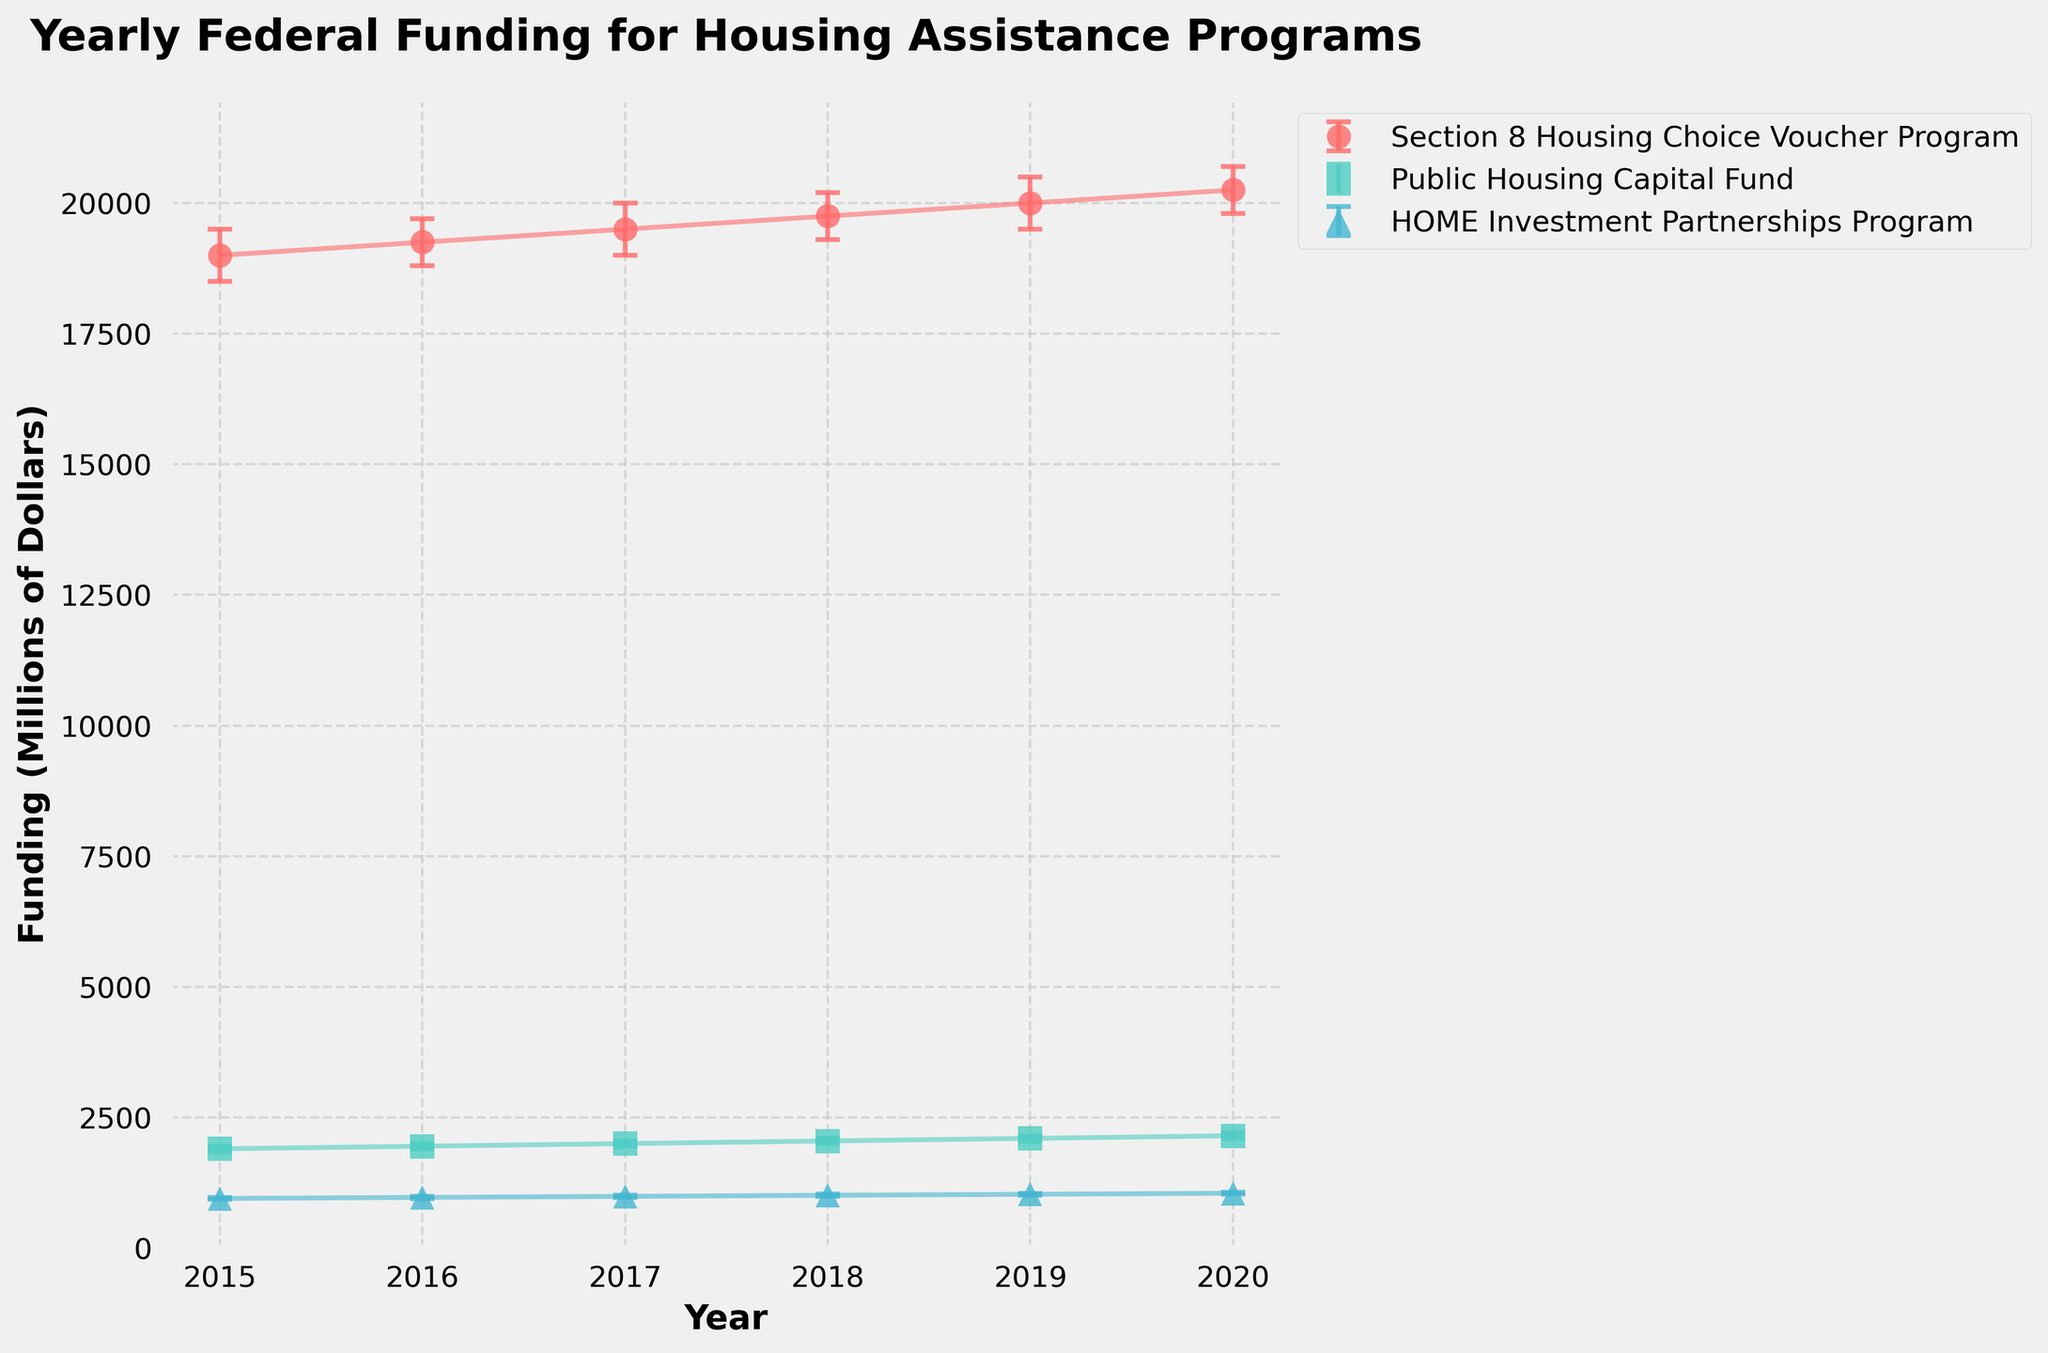What is the title of the figure? The title of the figure is located at the top and provides a brief description of what the plot represents.
Answer: Yearly Federal Funding for Housing Assistance Programs What are the x-axis and y-axis labels in the plot? The x-axis label is typically below the horizontal axis and the y-axis label is typically beside the vertical axis. For this plot:
- The x-axis label is "Year".
- The y-axis label is "Funding (Millions of Dollars)".
Answer: x-axis: Year, y-axis: Funding (Millions of Dollars) What program received the highest funding in 2020? By locating the data point for the year 2020 on the x-axis and then identifying the highest data point along the y-axis, the Section 8 Housing Choice Voucher Program received the highest funding in 2020.
Answer: Section 8 Housing Choice Voucher Program Which year shows the lowest funding for the HOME Investment Partnerships Program, and what is that amount? By tracking the HOME Investment Partnerships Program across the years and identifying the lowest data point, the lowest funding occurs in 2015, with the amount being 950 million dollars.
Answer: 2015, 950 million dollars How does the funding for the Public Housing Capital Fund change from 2015 to 2020? By observing the data points for the Public Housing Capital Fund from 2015 to 2020, we see an increase from 1900 million dollars in 2015 to 2150 million dollars in 2020.
Answer: Increases from 1900 million dollars to 2150 million dollars Which program shows the smallest change in average funding from 2015 to 2020? By calculating the funding change for each program between 2015 and 2020:
- Section 8 Housing Choice Voucher Program: 20250 - 19000 = 1250
- Public Housing Capital Fund: 2150 - 1900 = 250
- HOME Investment Partnerships Program: 1050 - 950 = 100
The HOME Investment Partnerships Program shows the smallest change.
Answer: HOME Investment Partnerships Program What are the confidence intervals for the Section 8 Housing Choice Voucher Program in 2019? By focusing on the error bars for the Section 8 Housing Choice Voucher Program for the year 2019, we see that the lower confidence interval is 19500 million dollars and the upper confidence interval is 20500 million dollars.
Answer: 19500 to 20500 million dollars Did the average funding for the Section 8 Housing Choice Voucher Program consistently increase every year from 2015 to 2020? By examining the funding for the Section 8 Housing Choice Voucher Program across each year, there is a consistent increase each year from 19000 million dollars in 2015 to 20250 million dollars in 2020.
Answer: Yes Which year has the narrowest confidence interval for the HOME Investment Partnerships Program, and what is the interval width? By comparing the width of the confidence intervals for the HOME Investment Partnerships Program across the years, the year 2015 has the narrowest interval:
- Interval width for 2015: 970 - 930 = 40 million dollars.
Answer: 2015, 40 million dollars Which program shows the largest average funding difference between the years 2018 and 2019? By calculating the funding difference for each program between 2018 and 2019:
- Section 8 Housing Choice Voucher Program: 20000 - 19750 = 250
- Public Housing Capital Fund: 2100 - 2050 = 50
- HOME Investment Partnerships Program: 1030 - 1010 = 20
The Section 8 Housing Choice Voucher Program shows the largest difference.
Answer: Section 8 Housing Choice Voucher Program 